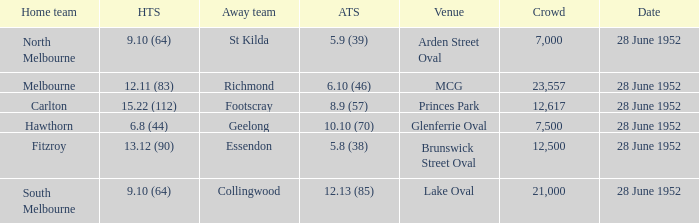What is the away team when north melbourne is at home? St Kilda. 